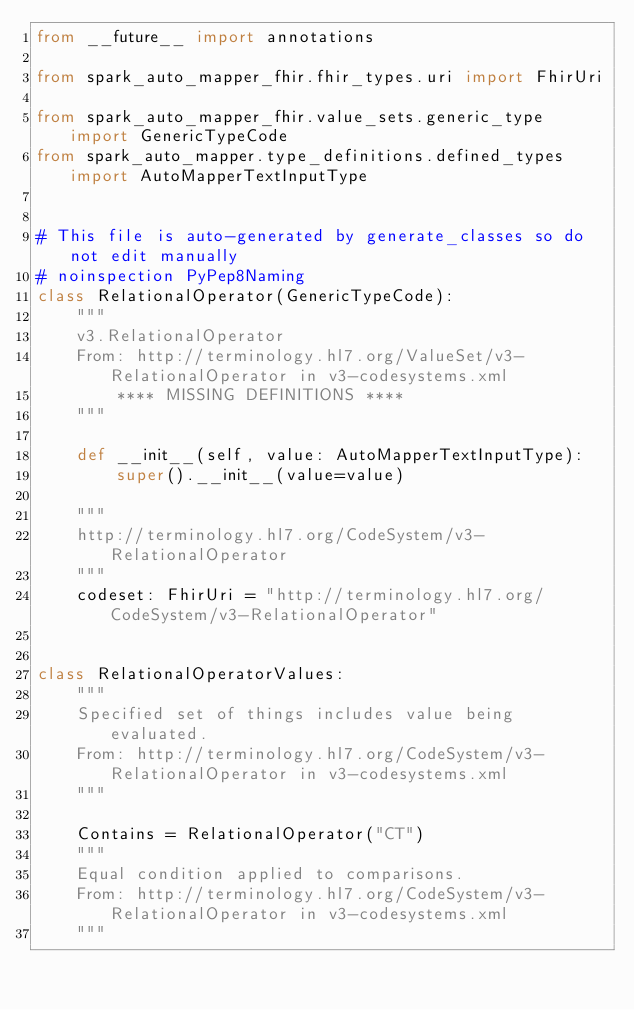<code> <loc_0><loc_0><loc_500><loc_500><_Python_>from __future__ import annotations

from spark_auto_mapper_fhir.fhir_types.uri import FhirUri

from spark_auto_mapper_fhir.value_sets.generic_type import GenericTypeCode
from spark_auto_mapper.type_definitions.defined_types import AutoMapperTextInputType


# This file is auto-generated by generate_classes so do not edit manually
# noinspection PyPep8Naming
class RelationalOperator(GenericTypeCode):
    """
    v3.RelationalOperator
    From: http://terminology.hl7.org/ValueSet/v3-RelationalOperator in v3-codesystems.xml
        **** MISSING DEFINITIONS ****
    """

    def __init__(self, value: AutoMapperTextInputType):
        super().__init__(value=value)

    """
    http://terminology.hl7.org/CodeSystem/v3-RelationalOperator
    """
    codeset: FhirUri = "http://terminology.hl7.org/CodeSystem/v3-RelationalOperator"


class RelationalOperatorValues:
    """
    Specified set of things includes value being evaluated.
    From: http://terminology.hl7.org/CodeSystem/v3-RelationalOperator in v3-codesystems.xml
    """

    Contains = RelationalOperator("CT")
    """
    Equal condition applied to comparisons.
    From: http://terminology.hl7.org/CodeSystem/v3-RelationalOperator in v3-codesystems.xml
    """</code> 